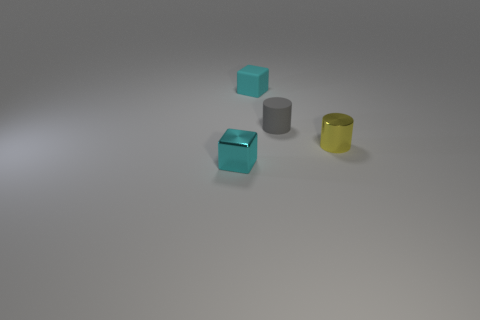Add 2 matte objects. How many objects exist? 6 Add 1 large brown metallic cubes. How many large brown metallic cubes exist? 1 Subtract 0 red cubes. How many objects are left? 4 Subtract all cubes. Subtract all tiny yellow things. How many objects are left? 1 Add 4 small gray objects. How many small gray objects are left? 5 